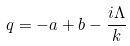<formula> <loc_0><loc_0><loc_500><loc_500>q = - a + b - \frac { i \Lambda } { k }</formula> 